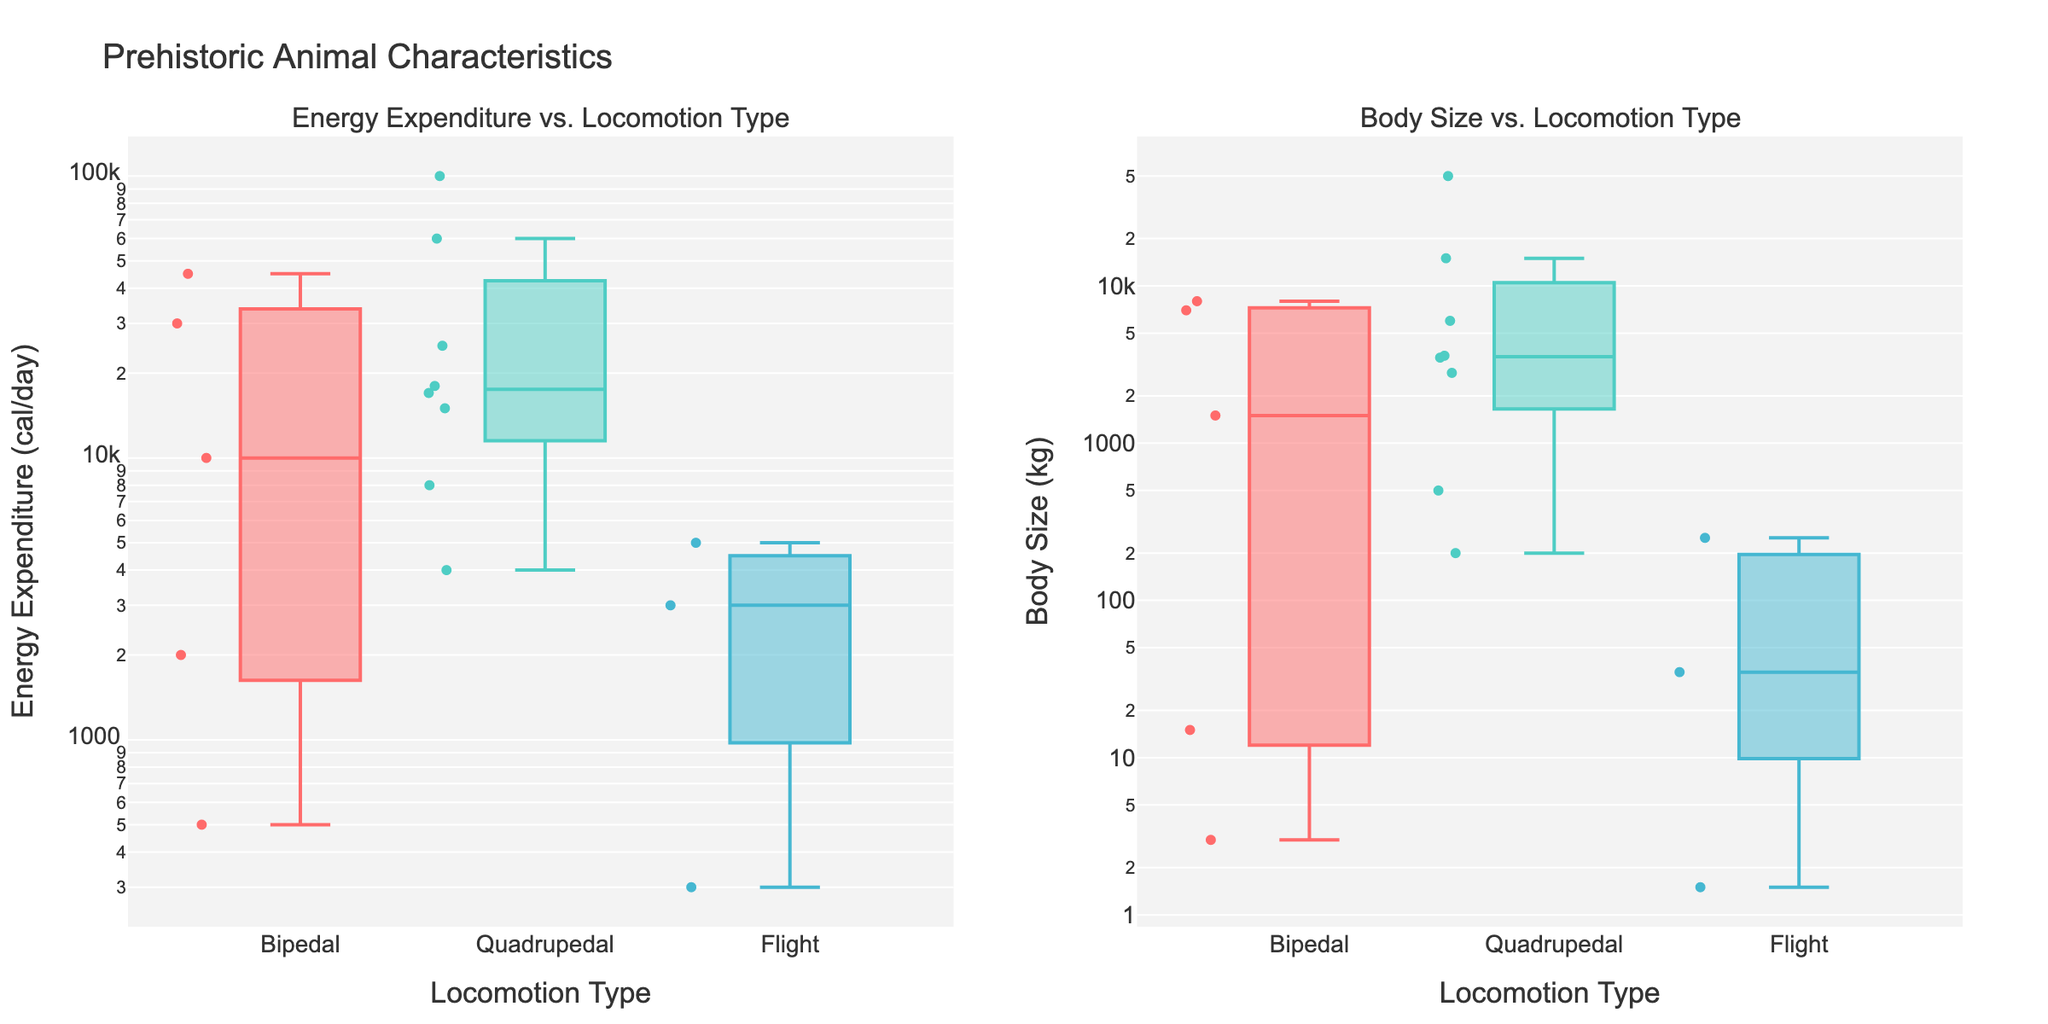What is the title of the figure? The title is located at the top of the figure and provides a summary of what the chart represents. It reads "Prehistoric Animal Characteristics".
Answer: Prehistoric Animal Characteristics What does the y-axis represent in the first box plot? The y-axis title in the first box plot reads "Energy Expenditure (cal/day)". This means the y-axis shows the energy expenditure of the prehistoric animals in calories per day, on a logarithmic scale.
Answer: Energy Expenditure (cal/day) Which locomotion type has the highest median body size? The median values of body sizes are indicated by the central line in each box of the body size box plot. The "Quadrupedal" category has the highest median body size.
Answer: Quadrupedal How many different locomotion types are shown in the plots? The legend of the plots and the x-axes labels show the different locomotion types included in the data. There are three types: "Bipedal", "Quadrupedal", and "Flight".
Answer: Three Which species has the lowest energy expenditure and what is its locomotion type? The lowest point in the Energy Expenditure plot can be used to identify the species. "Archaeopteryx" has the lowest energy expenditure at 300 cal/day and it belongs to the "Flight" locomotion type.
Answer: Archaeopteryx; Flight What is the general trend between body size and energy expenditure for Quadrupedal animals? By comparing the median lines of the Quadrupedal locomotion type across both plots, it is observed that body size and energy expenditure are positively correlated; larger body sizes generally correspond to higher energy expenditures.
Answer: Positive correlation Which species has the highest energy expenditure and what is its locomotion type? The highest point in the Energy Expenditure plot corresponds to the species "Brachiosaurus" with an expenditure of 100,000 cal/day, belonging to the "Quadrupedal" locomotion type.
Answer: Brachiosaurus; Quadrupedal Compare the spread of energy expenditure values between Bipedal and Flight locomotion types. Which type shows more variability based on this plot? The spread is indicated by the length of the boxes and the whiskers. The "Bipedal" type shows more variability as its box and whiskers cover a wider range of energy expenditure values compared to the "Flight" type.
Answer: Bipedal Which locomotion type has the smallest range of body sizes according to the box plot? By looking at the length of the boxes and whiskers in the body size plot, the "Flight" locomotion type shows the smallest range in body sizes.
Answer: Flight 